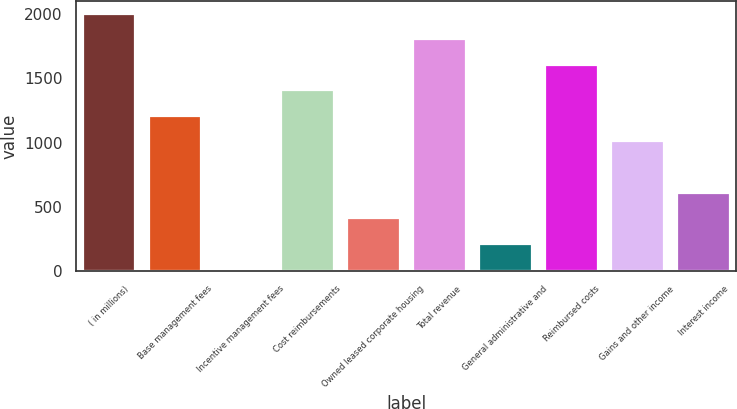<chart> <loc_0><loc_0><loc_500><loc_500><bar_chart><fcel>( in millions)<fcel>Base management fees<fcel>Incentive management fees<fcel>Cost reimbursements<fcel>Owned leased corporate housing<fcel>Total revenue<fcel>General administrative and<fcel>Reimbursed costs<fcel>Gains and other income<fcel>Interest income<nl><fcel>2005<fcel>1208.6<fcel>14<fcel>1407.7<fcel>412.2<fcel>1805.9<fcel>213.1<fcel>1606.8<fcel>1009.5<fcel>611.3<nl></chart> 